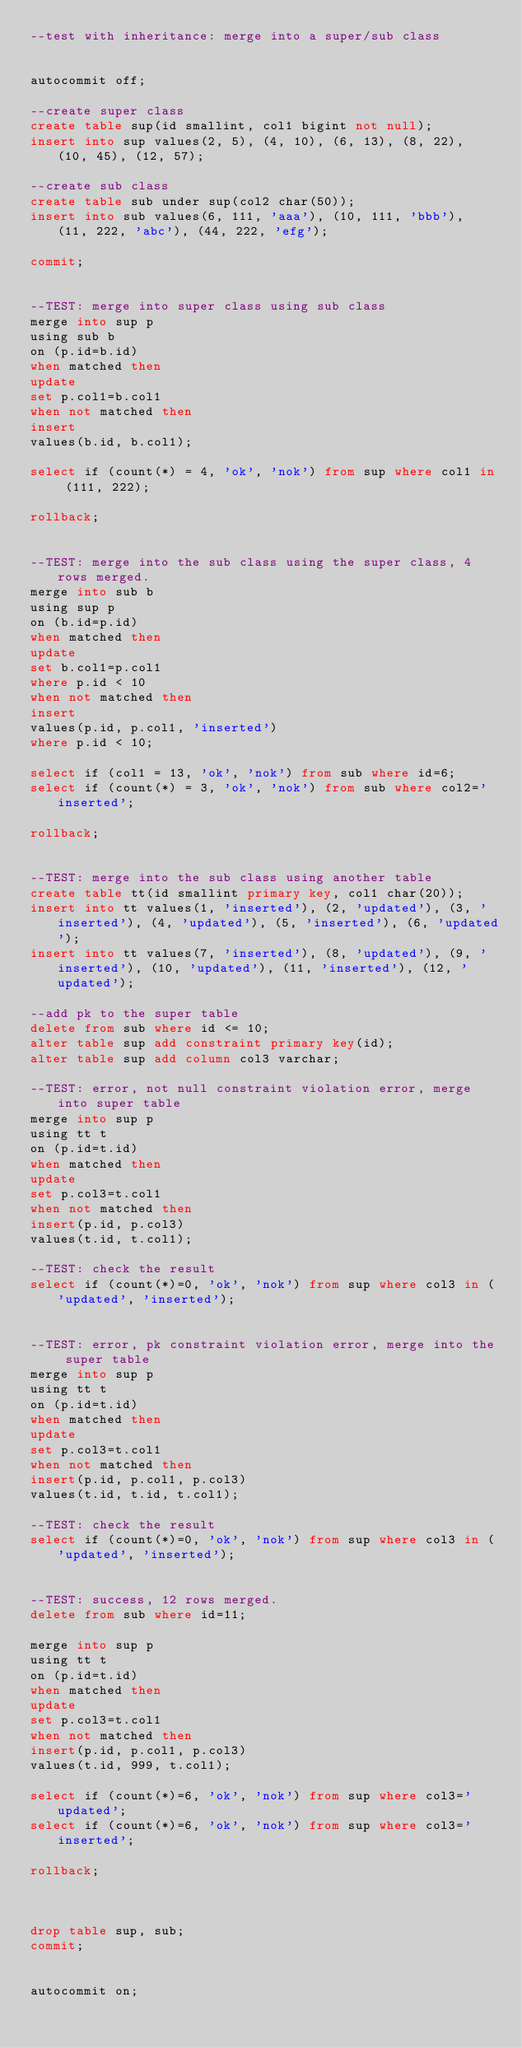Convert code to text. <code><loc_0><loc_0><loc_500><loc_500><_SQL_>--test with inheritance: merge into a super/sub class


autocommit off;

--create super class
create table sup(id smallint, col1 bigint not null);
insert into sup values(2, 5), (4, 10), (6, 13), (8, 22), (10, 45), (12, 57);

--create sub class
create table sub under sup(col2 char(50));
insert into sub values(6, 111, 'aaa'), (10, 111, 'bbb'), (11, 222, 'abc'), (44, 222, 'efg');

commit;


--TEST: merge into super class using sub class
merge into sup p
using sub b
on (p.id=b.id)
when matched then
update
set p.col1=b.col1
when not matched then 
insert
values(b.id, b.col1);

select if (count(*) = 4, 'ok', 'nok') from sup where col1 in (111, 222);

rollback;


--TEST: merge into the sub class using the super class, 4 rows merged.
merge into sub b
using sup p
on (b.id=p.id)
when matched then
update
set b.col1=p.col1
where p.id < 10
when not matched then
insert
values(p.id, p.col1, 'inserted')
where p.id < 10;

select if (col1 = 13, 'ok', 'nok') from sub where id=6;
select if (count(*) = 3, 'ok', 'nok') from sub where col2='inserted';

rollback;


--TEST: merge into the sub class using another table
create table tt(id smallint primary key, col1 char(20));
insert into tt values(1, 'inserted'), (2, 'updated'), (3, 'inserted'), (4, 'updated'), (5, 'inserted'), (6, 'updated');
insert into tt values(7, 'inserted'), (8, 'updated'), (9, 'inserted'), (10, 'updated'), (11, 'inserted'), (12, 'updated');

--add pk to the super table
delete from sub where id <= 10;
alter table sup add constraint primary key(id);
alter table sup add column col3 varchar;

--TEST: error, not null constraint violation error, merge into super table
merge into sup p
using tt t
on (p.id=t.id)
when matched then
update
set p.col3=t.col1
when not matched then
insert(p.id, p.col3)
values(t.id, t.col1);

--TEST: check the result
select if (count(*)=0, 'ok', 'nok') from sup where col3 in ('updated', 'inserted');


--TEST: error, pk constraint violation error, merge into the super table
merge into sup p
using tt t
on (p.id=t.id)
when matched then
update
set p.col3=t.col1
when not matched then
insert(p.id, p.col1, p.col3)
values(t.id, t.id, t.col1);

--TEST: check the result
select if (count(*)=0, 'ok', 'nok') from sup where col3 in ('updated', 'inserted');


--TEST: success, 12 rows merged.
delete from sub where id=11;

merge into sup p
using tt t
on (p.id=t.id)
when matched then
update
set p.col3=t.col1
when not matched then
insert(p.id, p.col1, p.col3)
values(t.id, 999, t.col1);

select if (count(*)=6, 'ok', 'nok') from sup where col3='updated';
select if (count(*)=6, 'ok', 'nok') from sup where col3='inserted';

rollback;



drop table sup, sub;
commit;


autocommit on;


</code> 